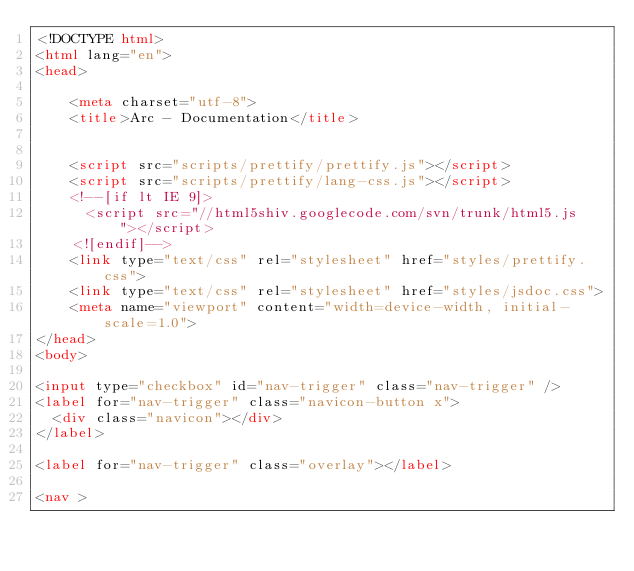Convert code to text. <code><loc_0><loc_0><loc_500><loc_500><_HTML_><!DOCTYPE html>
<html lang="en">
<head>
    
    <meta charset="utf-8">
    <title>Arc - Documentation</title>
    
    
    <script src="scripts/prettify/prettify.js"></script>
    <script src="scripts/prettify/lang-css.js"></script>
    <!--[if lt IE 9]>
      <script src="//html5shiv.googlecode.com/svn/trunk/html5.js"></script>
    <![endif]-->
    <link type="text/css" rel="stylesheet" href="styles/prettify.css">
    <link type="text/css" rel="stylesheet" href="styles/jsdoc.css">
    <meta name="viewport" content="width=device-width, initial-scale=1.0">
</head>
<body>

<input type="checkbox" id="nav-trigger" class="nav-trigger" />
<label for="nav-trigger" class="navicon-button x">
  <div class="navicon"></div>
</label>

<label for="nav-trigger" class="overlay"></label>

<nav >
    </code> 